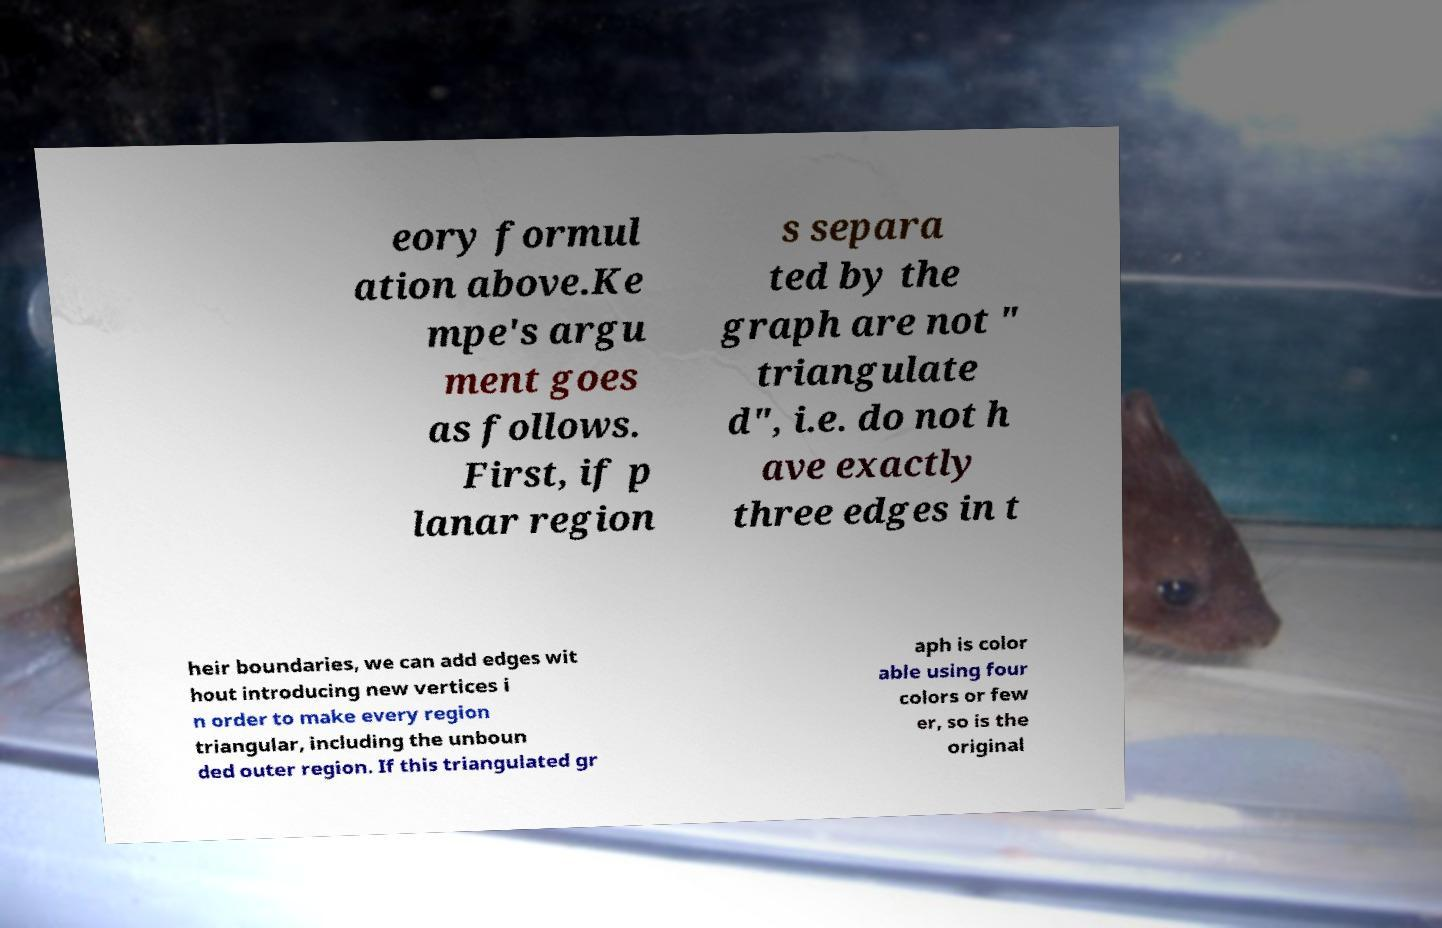Please identify and transcribe the text found in this image. eory formul ation above.Ke mpe's argu ment goes as follows. First, if p lanar region s separa ted by the graph are not " triangulate d", i.e. do not h ave exactly three edges in t heir boundaries, we can add edges wit hout introducing new vertices i n order to make every region triangular, including the unboun ded outer region. If this triangulated gr aph is color able using four colors or few er, so is the original 